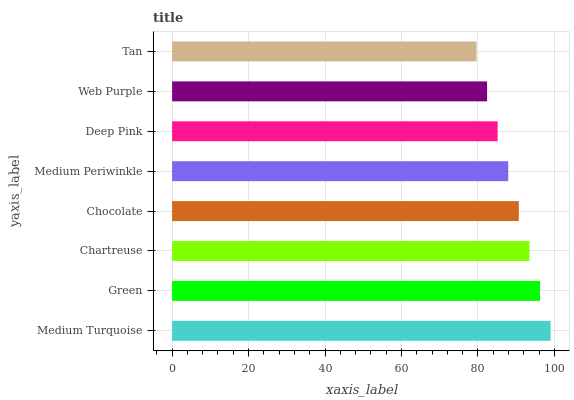Is Tan the minimum?
Answer yes or no. Yes. Is Medium Turquoise the maximum?
Answer yes or no. Yes. Is Green the minimum?
Answer yes or no. No. Is Green the maximum?
Answer yes or no. No. Is Medium Turquoise greater than Green?
Answer yes or no. Yes. Is Green less than Medium Turquoise?
Answer yes or no. Yes. Is Green greater than Medium Turquoise?
Answer yes or no. No. Is Medium Turquoise less than Green?
Answer yes or no. No. Is Chocolate the high median?
Answer yes or no. Yes. Is Medium Periwinkle the low median?
Answer yes or no. Yes. Is Green the high median?
Answer yes or no. No. Is Web Purple the low median?
Answer yes or no. No. 